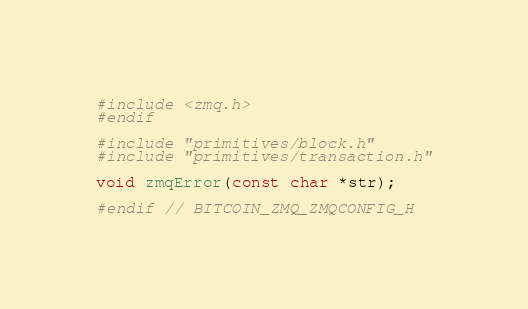<code> <loc_0><loc_0><loc_500><loc_500><_C_>#include <zmq.h>
#endif

#include "primitives/block.h"
#include "primitives/transaction.h"

void zmqError(const char *str);

#endif // BITCOIN_ZMQ_ZMQCONFIG_H
</code> 